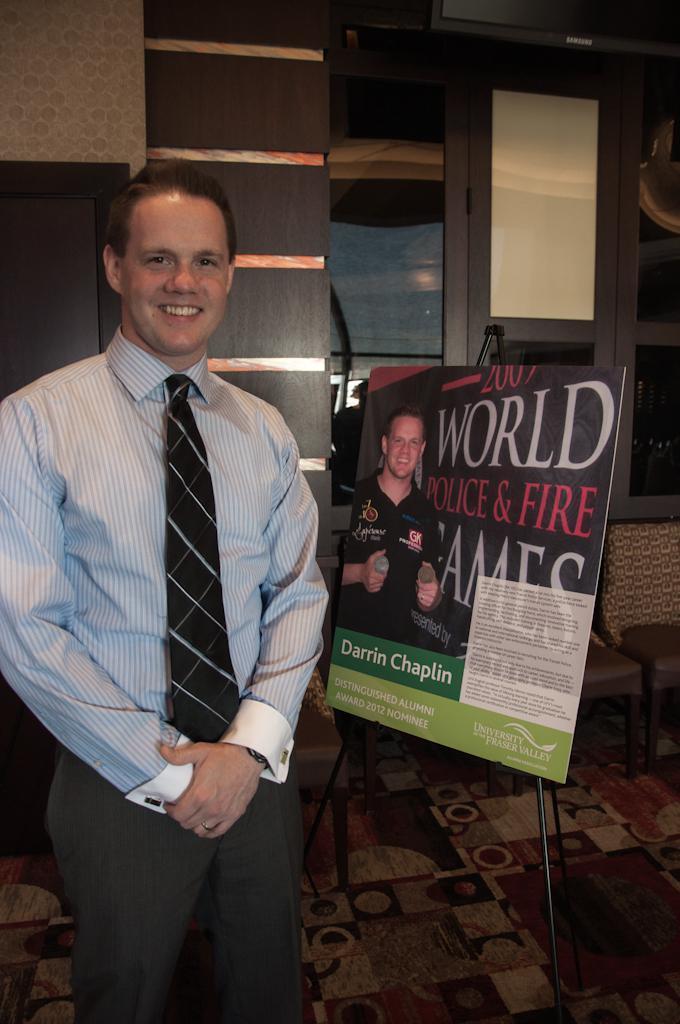Describe this image in one or two sentences. There is a man standing on the floor and he is smiling. Here we can see a board, chairs, glasses, and a wall. 